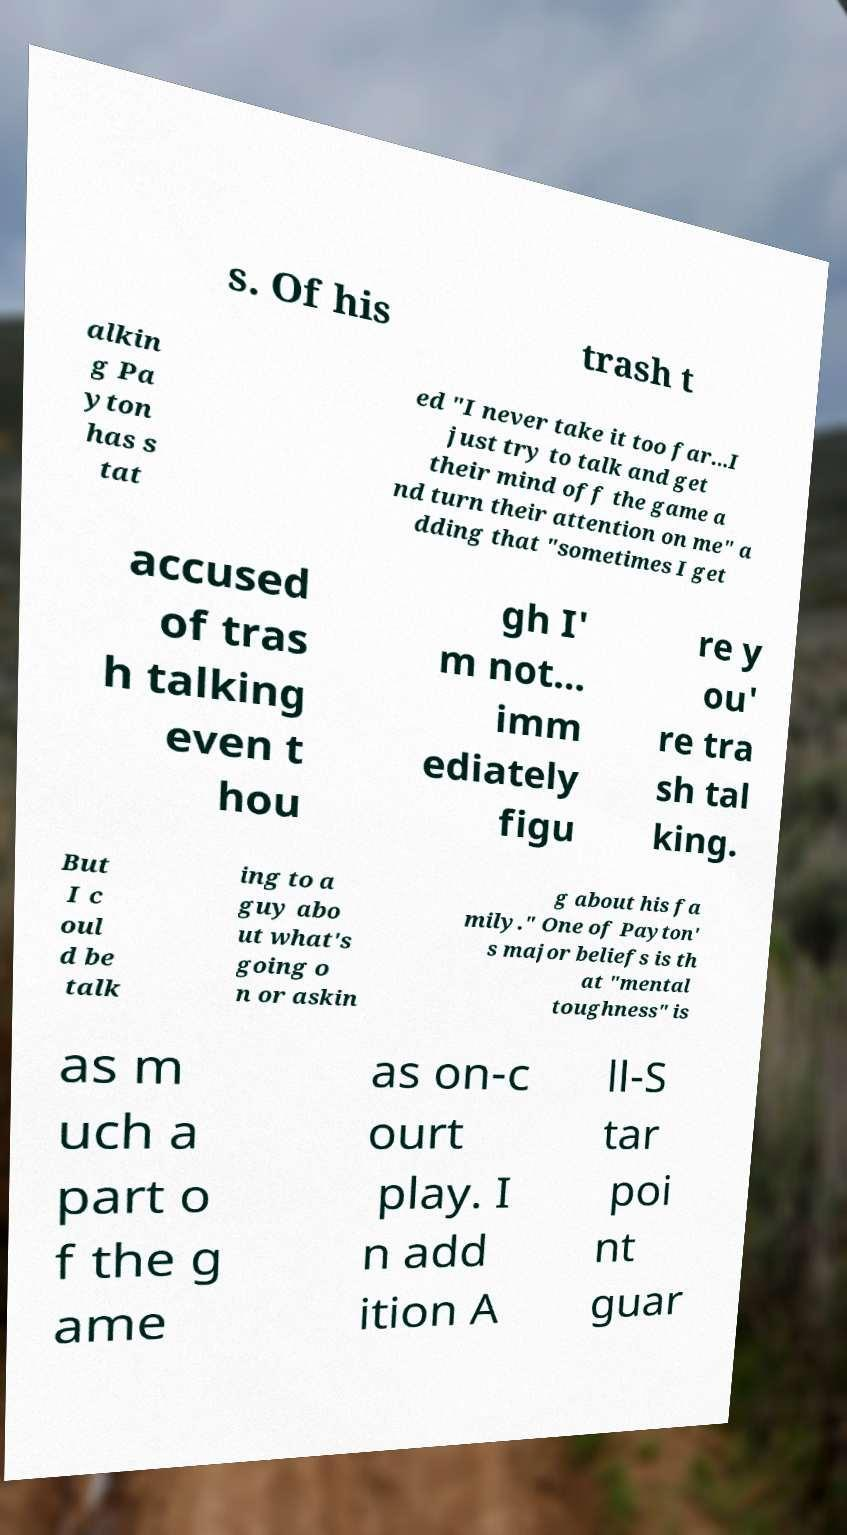Could you extract and type out the text from this image? s. Of his trash t alkin g Pa yton has s tat ed "I never take it too far...I just try to talk and get their mind off the game a nd turn their attention on me" a dding that "sometimes I get accused of tras h talking even t hou gh I' m not... imm ediately figu re y ou' re tra sh tal king. But I c oul d be talk ing to a guy abo ut what's going o n or askin g about his fa mily." One of Payton' s major beliefs is th at "mental toughness" is as m uch a part o f the g ame as on-c ourt play. I n add ition A ll-S tar poi nt guar 